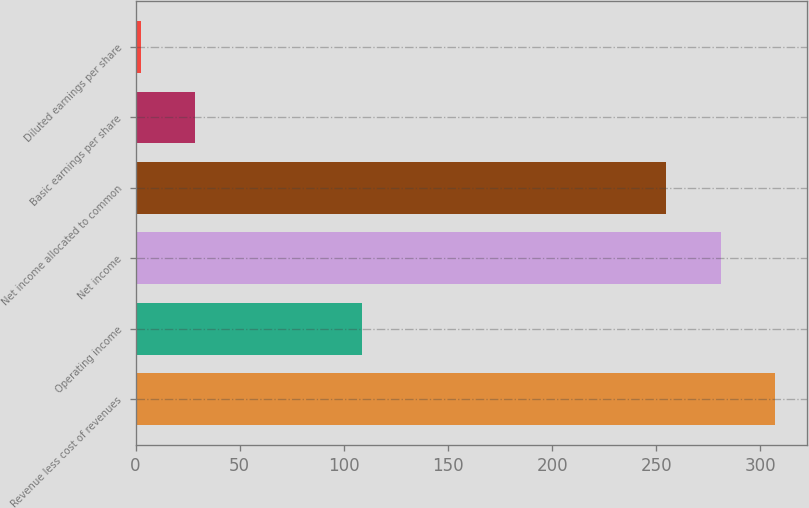<chart> <loc_0><loc_0><loc_500><loc_500><bar_chart><fcel>Revenue less cost of revenues<fcel>Operating income<fcel>Net income<fcel>Net income allocated to common<fcel>Basic earnings per share<fcel>Diluted earnings per share<nl><fcel>307.24<fcel>108.7<fcel>280.92<fcel>254.6<fcel>28.72<fcel>2.4<nl></chart> 